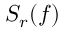Convert formula to latex. <formula><loc_0><loc_0><loc_500><loc_500>S _ { r } ( f )</formula> 